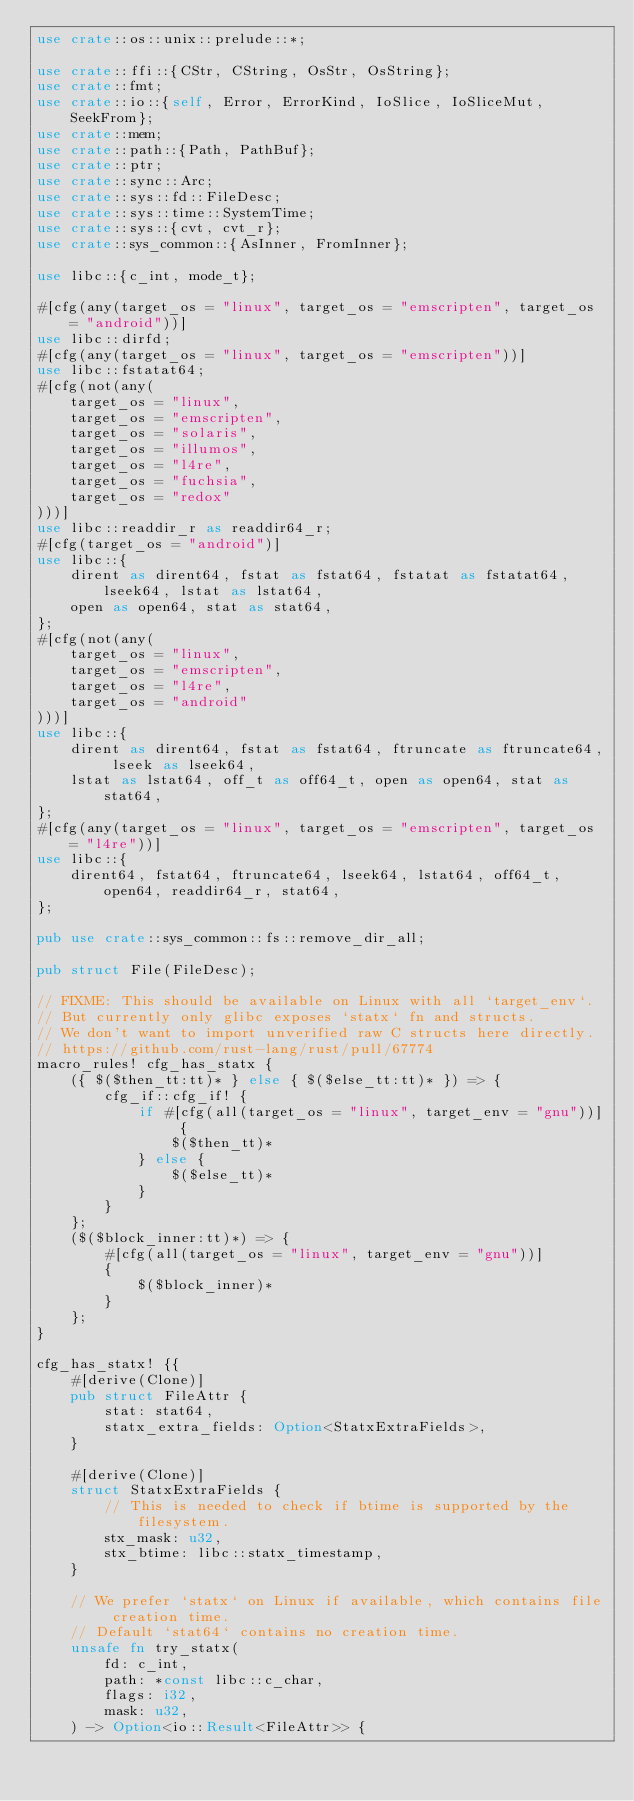<code> <loc_0><loc_0><loc_500><loc_500><_Rust_>use crate::os::unix::prelude::*;

use crate::ffi::{CStr, CString, OsStr, OsString};
use crate::fmt;
use crate::io::{self, Error, ErrorKind, IoSlice, IoSliceMut, SeekFrom};
use crate::mem;
use crate::path::{Path, PathBuf};
use crate::ptr;
use crate::sync::Arc;
use crate::sys::fd::FileDesc;
use crate::sys::time::SystemTime;
use crate::sys::{cvt, cvt_r};
use crate::sys_common::{AsInner, FromInner};

use libc::{c_int, mode_t};

#[cfg(any(target_os = "linux", target_os = "emscripten", target_os = "android"))]
use libc::dirfd;
#[cfg(any(target_os = "linux", target_os = "emscripten"))]
use libc::fstatat64;
#[cfg(not(any(
    target_os = "linux",
    target_os = "emscripten",
    target_os = "solaris",
    target_os = "illumos",
    target_os = "l4re",
    target_os = "fuchsia",
    target_os = "redox"
)))]
use libc::readdir_r as readdir64_r;
#[cfg(target_os = "android")]
use libc::{
    dirent as dirent64, fstat as fstat64, fstatat as fstatat64, lseek64, lstat as lstat64,
    open as open64, stat as stat64,
};
#[cfg(not(any(
    target_os = "linux",
    target_os = "emscripten",
    target_os = "l4re",
    target_os = "android"
)))]
use libc::{
    dirent as dirent64, fstat as fstat64, ftruncate as ftruncate64, lseek as lseek64,
    lstat as lstat64, off_t as off64_t, open as open64, stat as stat64,
};
#[cfg(any(target_os = "linux", target_os = "emscripten", target_os = "l4re"))]
use libc::{
    dirent64, fstat64, ftruncate64, lseek64, lstat64, off64_t, open64, readdir64_r, stat64,
};

pub use crate::sys_common::fs::remove_dir_all;

pub struct File(FileDesc);

// FIXME: This should be available on Linux with all `target_env`.
// But currently only glibc exposes `statx` fn and structs.
// We don't want to import unverified raw C structs here directly.
// https://github.com/rust-lang/rust/pull/67774
macro_rules! cfg_has_statx {
    ({ $($then_tt:tt)* } else { $($else_tt:tt)* }) => {
        cfg_if::cfg_if! {
            if #[cfg(all(target_os = "linux", target_env = "gnu"))] {
                $($then_tt)*
            } else {
                $($else_tt)*
            }
        }
    };
    ($($block_inner:tt)*) => {
        #[cfg(all(target_os = "linux", target_env = "gnu"))]
        {
            $($block_inner)*
        }
    };
}

cfg_has_statx! {{
    #[derive(Clone)]
    pub struct FileAttr {
        stat: stat64,
        statx_extra_fields: Option<StatxExtraFields>,
    }

    #[derive(Clone)]
    struct StatxExtraFields {
        // This is needed to check if btime is supported by the filesystem.
        stx_mask: u32,
        stx_btime: libc::statx_timestamp,
    }

    // We prefer `statx` on Linux if available, which contains file creation time.
    // Default `stat64` contains no creation time.
    unsafe fn try_statx(
        fd: c_int,
        path: *const libc::c_char,
        flags: i32,
        mask: u32,
    ) -> Option<io::Result<FileAttr>> {</code> 